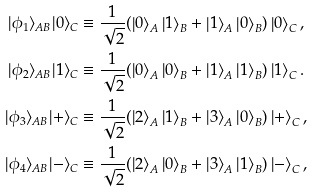Convert formula to latex. <formula><loc_0><loc_0><loc_500><loc_500>| \phi _ { 1 } \rangle _ { A B } | 0 \rangle _ { C } & \equiv \frac { 1 } { \sqrt { 2 } } ( \left | 0 \right \rangle _ { A } \left | 1 \right \rangle _ { B } + \left | 1 \right \rangle _ { A } \left | 0 \right \rangle _ { B } ) \left | 0 \right \rangle _ { C } , \\ | \phi _ { 2 } \rangle _ { A B } | 1 \rangle _ { C } & \equiv \frac { 1 } { \sqrt { 2 } } ( \left | 0 \right \rangle _ { A } \left | 0 \right \rangle _ { B } + \left | 1 \right \rangle _ { A } \left | 1 \right \rangle _ { B } ) \left | 1 \right \rangle _ { C } . \\ | \phi _ { 3 } \rangle _ { A B } | + \rangle _ { C } & \equiv \frac { 1 } { \sqrt { 2 } } ( \left | 2 \right \rangle _ { A } \left | 1 \right \rangle _ { B } + \left | 3 \right \rangle _ { A } \left | 0 \right \rangle _ { B } ) \left | + \right \rangle _ { C } , \\ | \phi _ { 4 } \rangle _ { A B } | - \rangle _ { C } & \equiv \frac { 1 } { \sqrt { 2 } } ( \left | 2 \right \rangle _ { A } \left | 0 \right \rangle _ { B } + \left | 3 \right \rangle _ { A } \left | 1 \right \rangle _ { B } ) \left | - \right \rangle _ { C } ,</formula> 